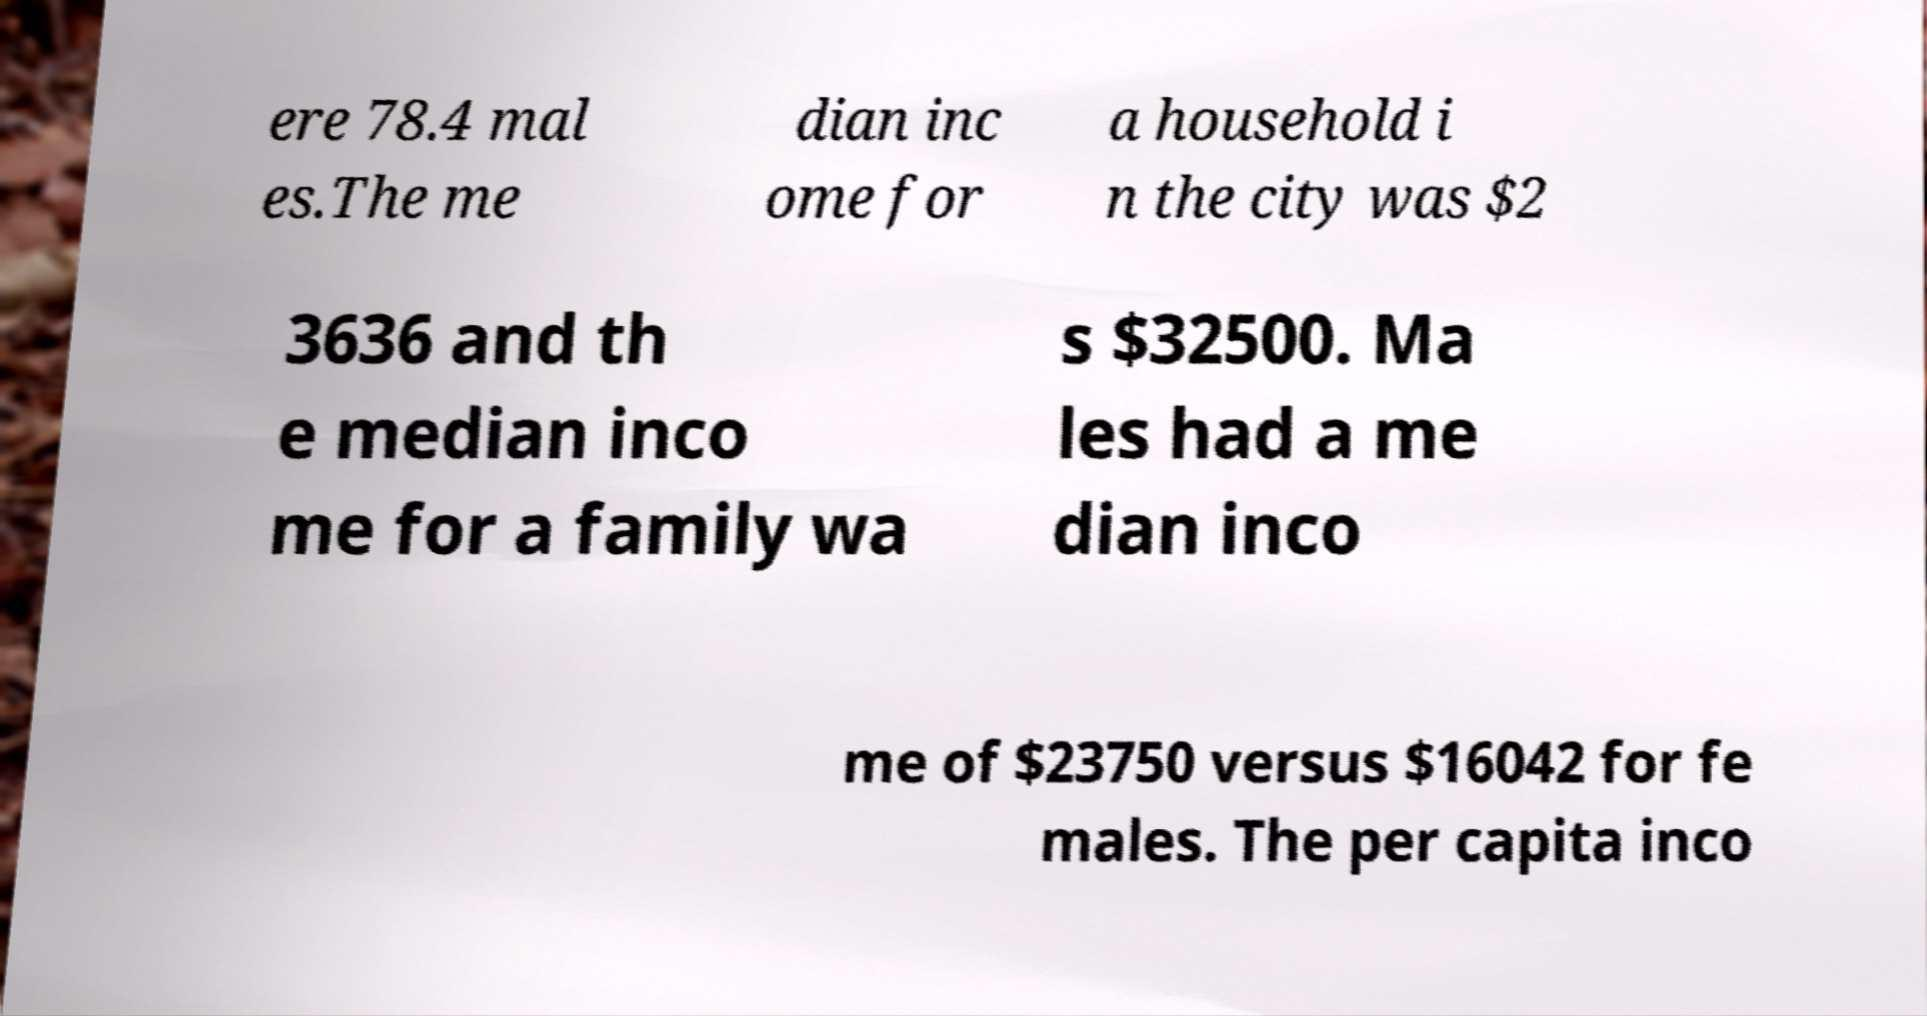Please identify and transcribe the text found in this image. ere 78.4 mal es.The me dian inc ome for a household i n the city was $2 3636 and th e median inco me for a family wa s $32500. Ma les had a me dian inco me of $23750 versus $16042 for fe males. The per capita inco 